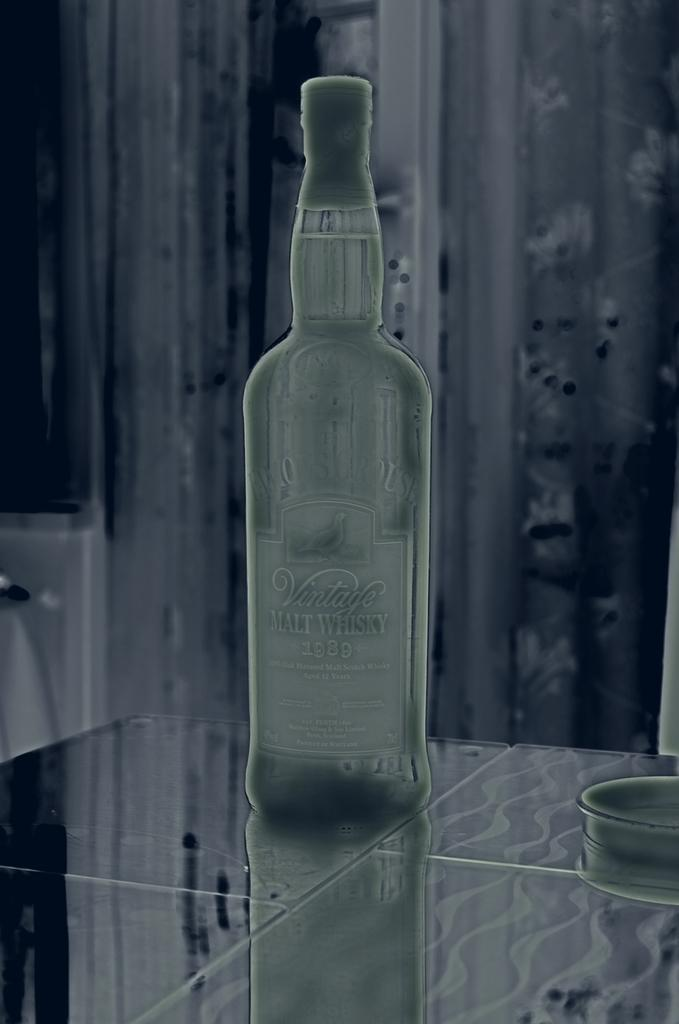What is the main object in the image? There is a whisky bottle in the image. Where is the whisky bottle placed? The whisky bottle is placed on a glass table. What type of elbow surgery is being performed in the image? There is no elbow or surgery present in the image; it only features a whisky bottle on a glass table. 